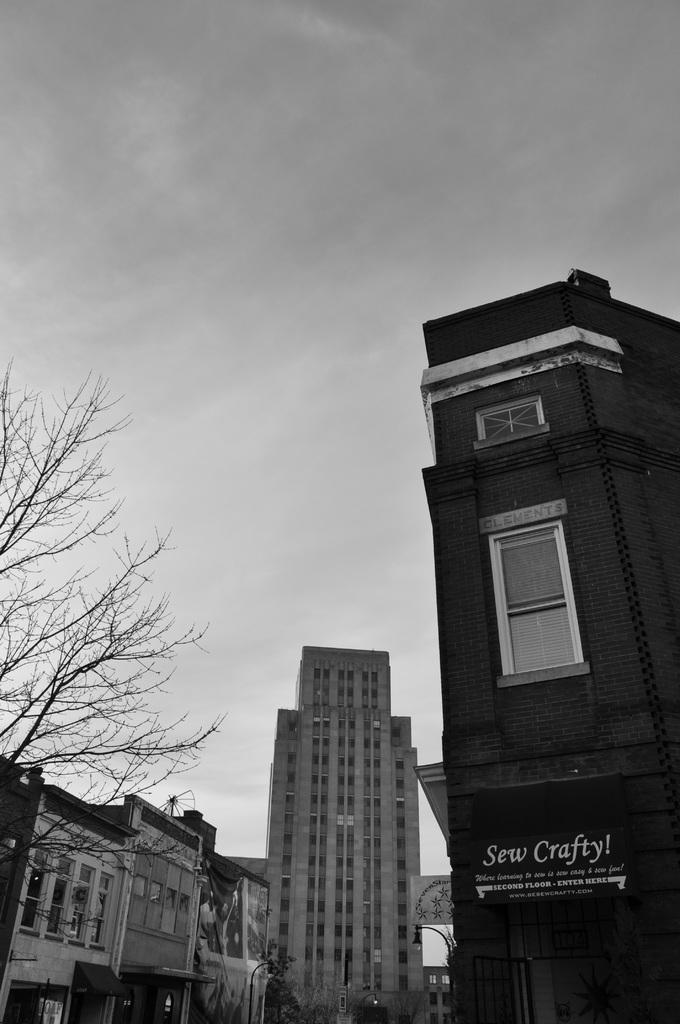What type of structures can be seen in the image? There are buildings in the image. What type of vegetation is present in the image? There are trees in the image. What part of the natural environment is visible in the image? The sky is visible in the image. Can you see any bananas hanging from the trees in the image? There are no bananas visible in the image; only trees are present. What type of toys can be seen scattered around the buildings in the image? There are no toys present in the image; only buildings and trees are visible. 